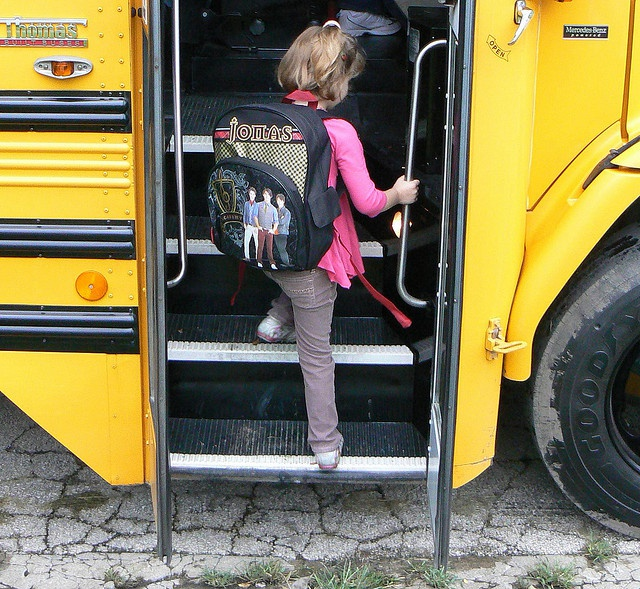Describe the objects in this image and their specific colors. I can see bus in black, gold, and gray tones and backpack in gold, black, gray, and white tones in this image. 